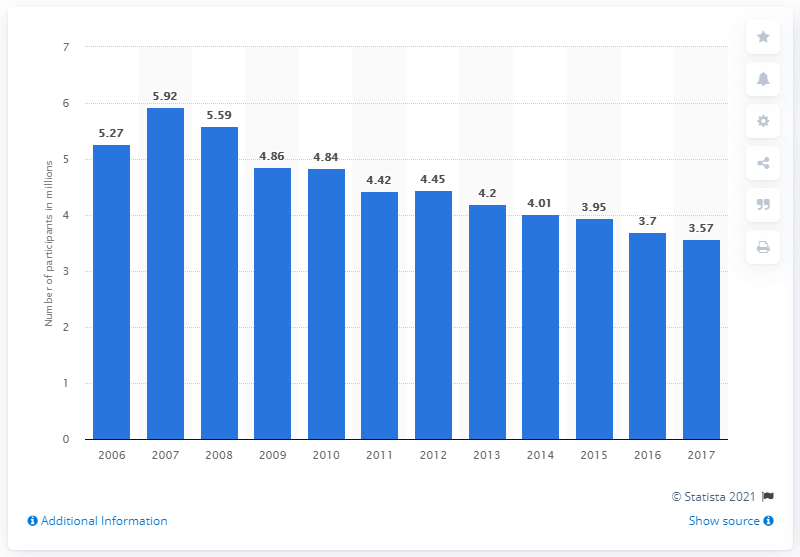Indicate a few pertinent items in this graphic. The total number of participants in water skiing in 2017 was 3.57. 